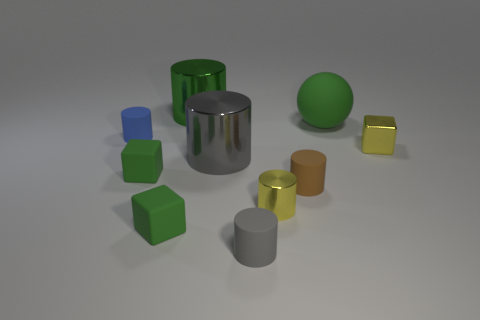Are there fewer rubber balls than small red rubber balls?
Offer a terse response. No. What number of cyan objects are matte blocks or metallic things?
Your answer should be very brief. 0. What number of tiny things are both to the left of the tiny yellow metal cylinder and in front of the small yellow metallic cube?
Make the answer very short. 3. Does the large green sphere have the same material as the large green cylinder?
Ensure brevity in your answer.  No. What is the shape of the gray rubber object that is the same size as the blue object?
Make the answer very short. Cylinder. Is the number of green rubber cubes greater than the number of cylinders?
Offer a very short reply. No. What material is the small thing that is both to the left of the gray matte object and behind the gray metal thing?
Offer a very short reply. Rubber. What number of other things are made of the same material as the small yellow cube?
Offer a very short reply. 3. What number of big things have the same color as the big ball?
Make the answer very short. 1. There is a green rubber object that is right of the metallic cylinder that is on the left side of the big object that is in front of the blue matte object; how big is it?
Make the answer very short. Large. 